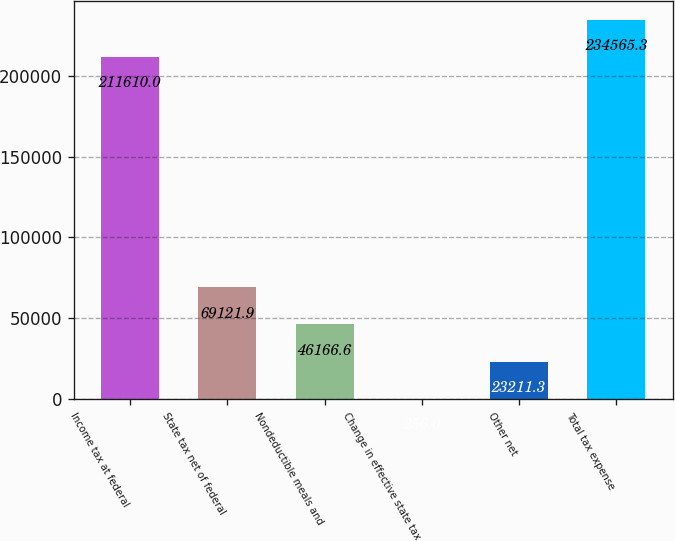Convert chart. <chart><loc_0><loc_0><loc_500><loc_500><bar_chart><fcel>Income tax at federal<fcel>State tax net of federal<fcel>Nondeductible meals and<fcel>Change in effective state tax<fcel>Other net<fcel>Total tax expense<nl><fcel>211610<fcel>69121.9<fcel>46166.6<fcel>256<fcel>23211.3<fcel>234565<nl></chart> 